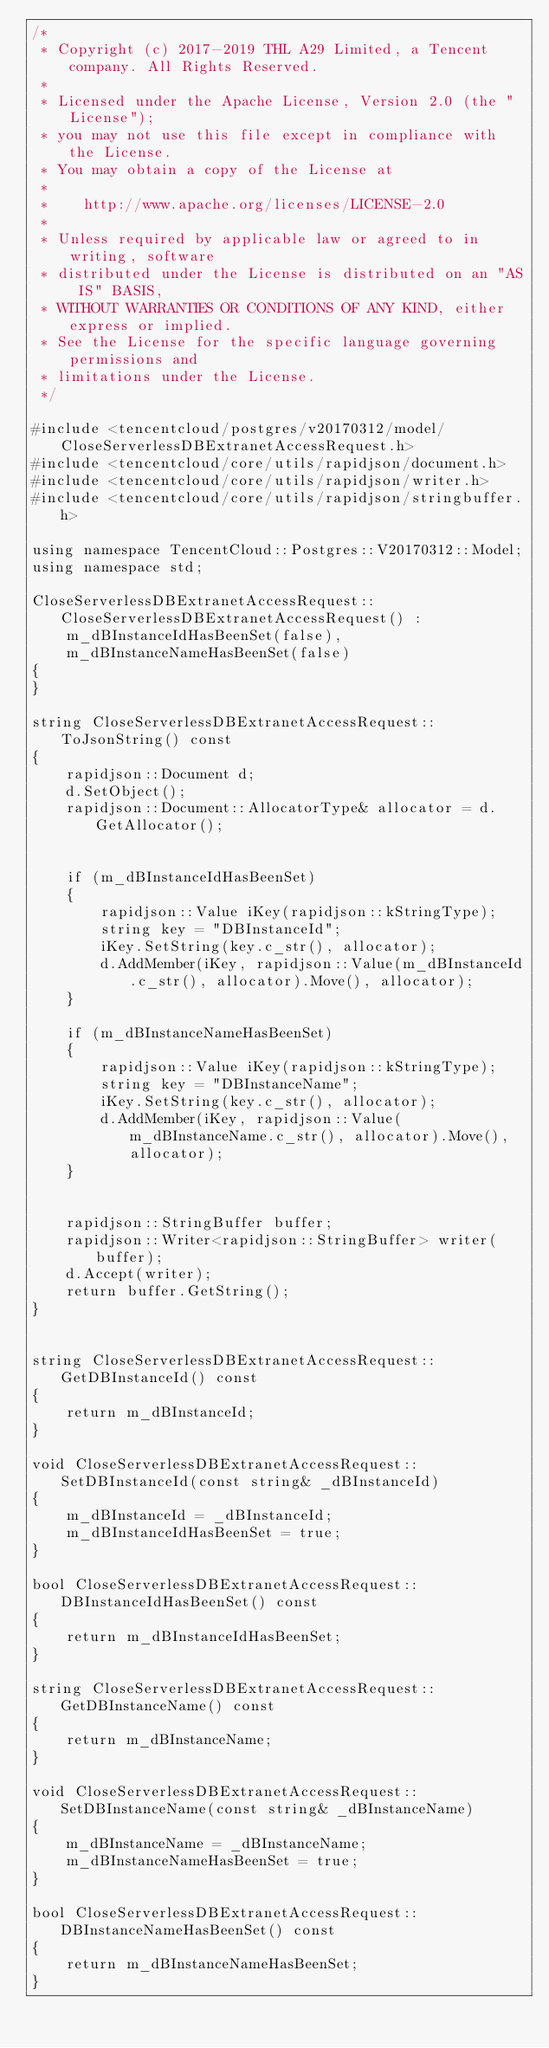Convert code to text. <code><loc_0><loc_0><loc_500><loc_500><_C++_>/*
 * Copyright (c) 2017-2019 THL A29 Limited, a Tencent company. All Rights Reserved.
 *
 * Licensed under the Apache License, Version 2.0 (the "License");
 * you may not use this file except in compliance with the License.
 * You may obtain a copy of the License at
 *
 *    http://www.apache.org/licenses/LICENSE-2.0
 *
 * Unless required by applicable law or agreed to in writing, software
 * distributed under the License is distributed on an "AS IS" BASIS,
 * WITHOUT WARRANTIES OR CONDITIONS OF ANY KIND, either express or implied.
 * See the License for the specific language governing permissions and
 * limitations under the License.
 */

#include <tencentcloud/postgres/v20170312/model/CloseServerlessDBExtranetAccessRequest.h>
#include <tencentcloud/core/utils/rapidjson/document.h>
#include <tencentcloud/core/utils/rapidjson/writer.h>
#include <tencentcloud/core/utils/rapidjson/stringbuffer.h>

using namespace TencentCloud::Postgres::V20170312::Model;
using namespace std;

CloseServerlessDBExtranetAccessRequest::CloseServerlessDBExtranetAccessRequest() :
    m_dBInstanceIdHasBeenSet(false),
    m_dBInstanceNameHasBeenSet(false)
{
}

string CloseServerlessDBExtranetAccessRequest::ToJsonString() const
{
    rapidjson::Document d;
    d.SetObject();
    rapidjson::Document::AllocatorType& allocator = d.GetAllocator();


    if (m_dBInstanceIdHasBeenSet)
    {
        rapidjson::Value iKey(rapidjson::kStringType);
        string key = "DBInstanceId";
        iKey.SetString(key.c_str(), allocator);
        d.AddMember(iKey, rapidjson::Value(m_dBInstanceId.c_str(), allocator).Move(), allocator);
    }

    if (m_dBInstanceNameHasBeenSet)
    {
        rapidjson::Value iKey(rapidjson::kStringType);
        string key = "DBInstanceName";
        iKey.SetString(key.c_str(), allocator);
        d.AddMember(iKey, rapidjson::Value(m_dBInstanceName.c_str(), allocator).Move(), allocator);
    }


    rapidjson::StringBuffer buffer;
    rapidjson::Writer<rapidjson::StringBuffer> writer(buffer);
    d.Accept(writer);
    return buffer.GetString();
}


string CloseServerlessDBExtranetAccessRequest::GetDBInstanceId() const
{
    return m_dBInstanceId;
}

void CloseServerlessDBExtranetAccessRequest::SetDBInstanceId(const string& _dBInstanceId)
{
    m_dBInstanceId = _dBInstanceId;
    m_dBInstanceIdHasBeenSet = true;
}

bool CloseServerlessDBExtranetAccessRequest::DBInstanceIdHasBeenSet() const
{
    return m_dBInstanceIdHasBeenSet;
}

string CloseServerlessDBExtranetAccessRequest::GetDBInstanceName() const
{
    return m_dBInstanceName;
}

void CloseServerlessDBExtranetAccessRequest::SetDBInstanceName(const string& _dBInstanceName)
{
    m_dBInstanceName = _dBInstanceName;
    m_dBInstanceNameHasBeenSet = true;
}

bool CloseServerlessDBExtranetAccessRequest::DBInstanceNameHasBeenSet() const
{
    return m_dBInstanceNameHasBeenSet;
}


</code> 